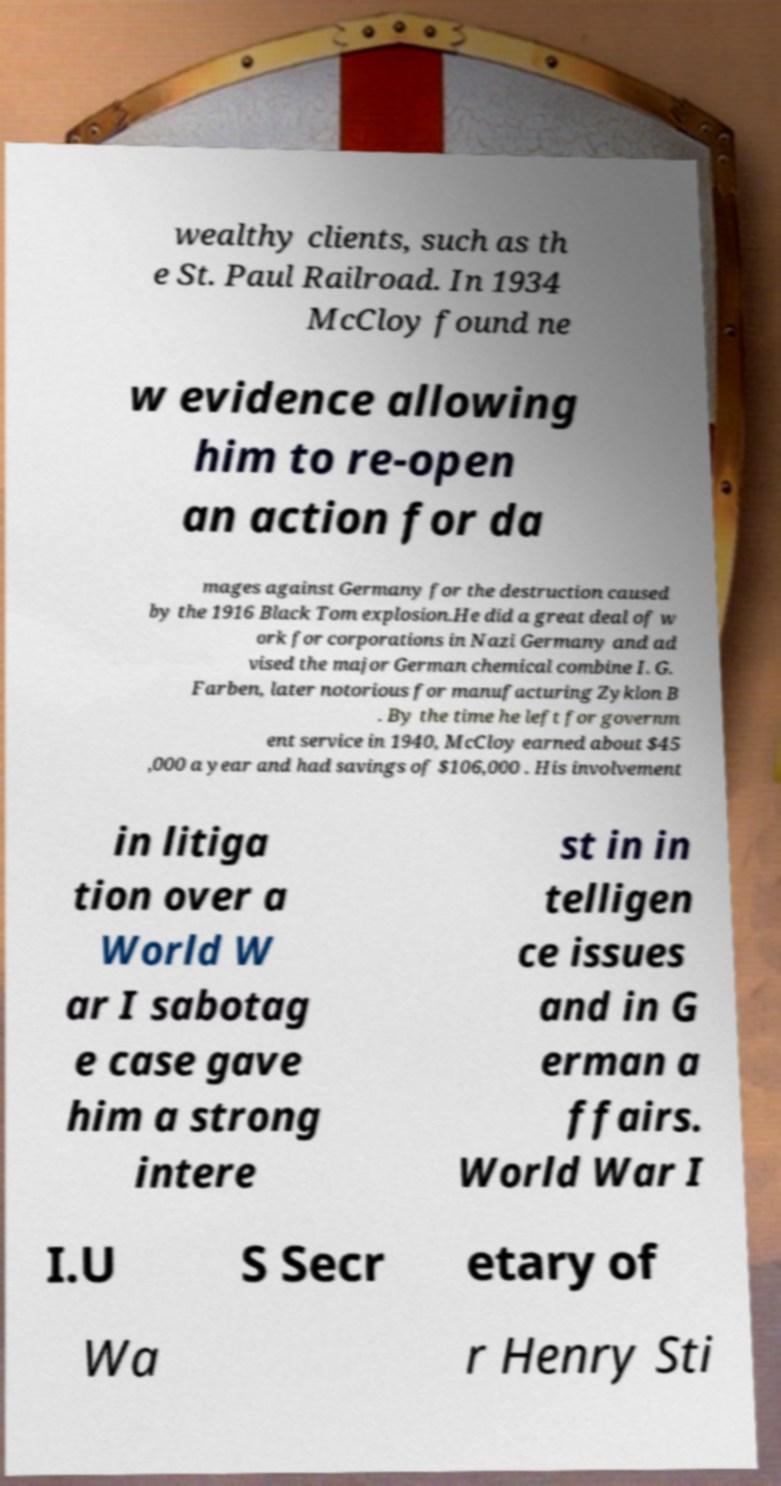For documentation purposes, I need the text within this image transcribed. Could you provide that? wealthy clients, such as th e St. Paul Railroad. In 1934 McCloy found ne w evidence allowing him to re-open an action for da mages against Germany for the destruction caused by the 1916 Black Tom explosion.He did a great deal of w ork for corporations in Nazi Germany and ad vised the major German chemical combine I. G. Farben, later notorious for manufacturing Zyklon B . By the time he left for governm ent service in 1940, McCloy earned about $45 ,000 a year and had savings of $106,000 . His involvement in litiga tion over a World W ar I sabotag e case gave him a strong intere st in in telligen ce issues and in G erman a ffairs. World War I I.U S Secr etary of Wa r Henry Sti 